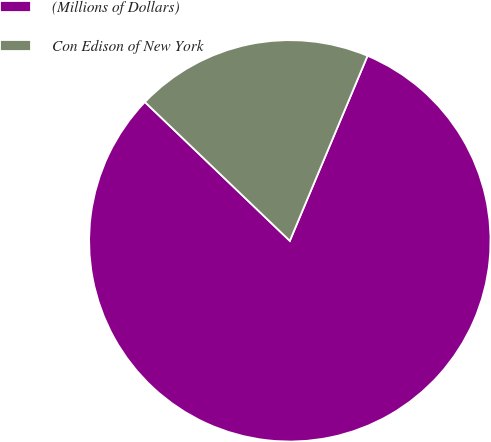<chart> <loc_0><loc_0><loc_500><loc_500><pie_chart><fcel>(Millions of Dollars)<fcel>Con Edison of New York<nl><fcel>80.83%<fcel>19.17%<nl></chart> 